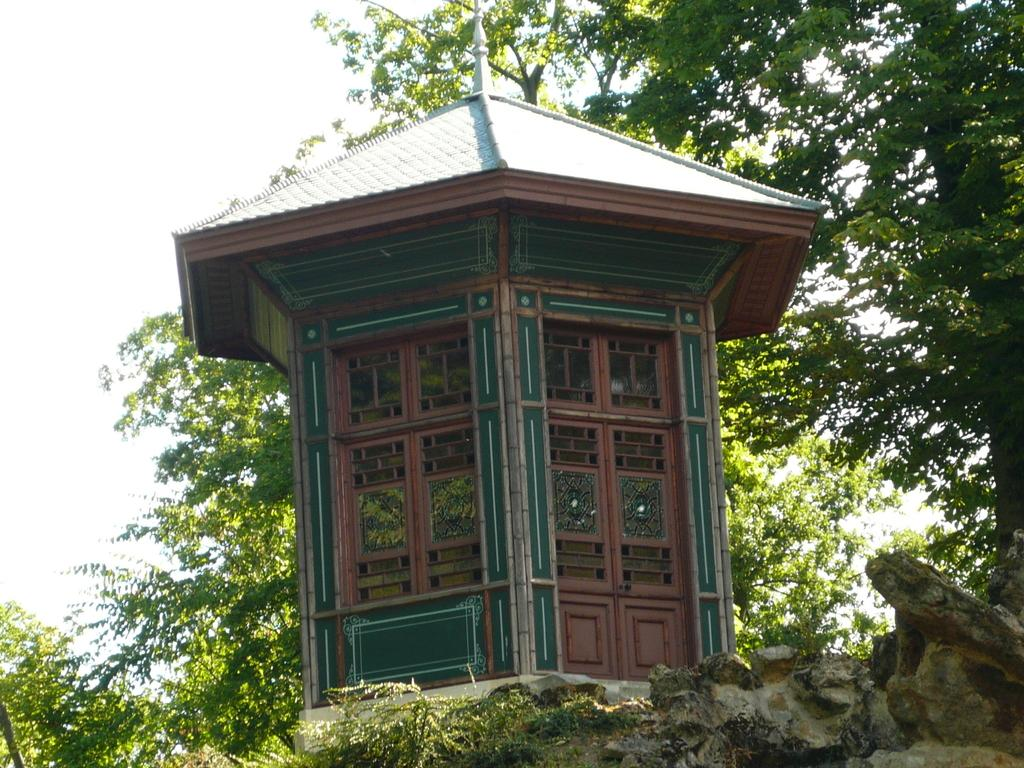What structure can be seen in the image? There is a shed in the image. What can be seen in the distance behind the shed? There are trees in the background of the image. What type of wall is present in the image? There is no wall present in the image; it features a shed and trees in the background. How does the image reflect the state of someone's mind? The image does not reflect the state of someone's mind; it is a visual representation of a shed and trees. 